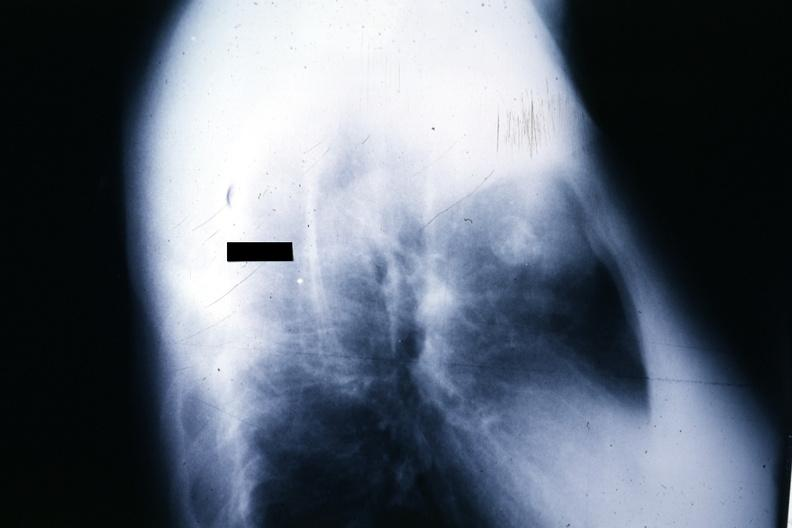s thymus present?
Answer the question using a single word or phrase. Yes 